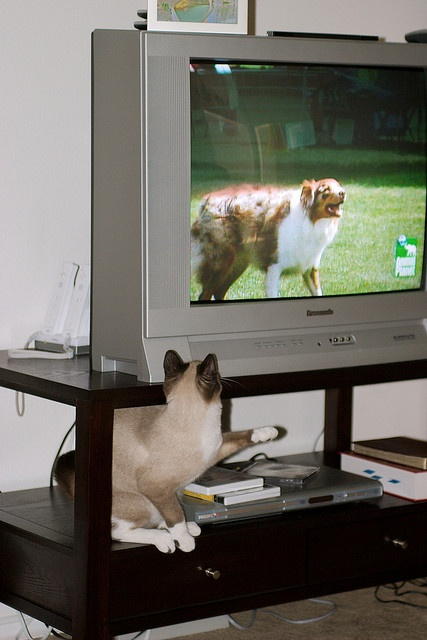Describe the objects in this image and their specific colors. I can see tv in lightgray, gray, black, and darkgreen tones, cat in lightgray, darkgray, and gray tones, dog in lightgray, darkgreen, gray, and tan tones, remote in lightgray and darkgray tones, and remote in lightgray and darkgray tones in this image. 